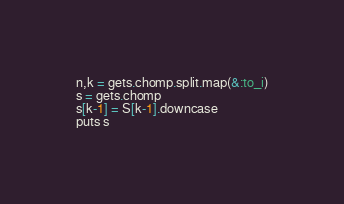<code> <loc_0><loc_0><loc_500><loc_500><_Ruby_>n,k = gets.chomp.split.map(&:to_i)
s = gets.chomp
s[k-1] = S[k-1].downcase
puts s</code> 